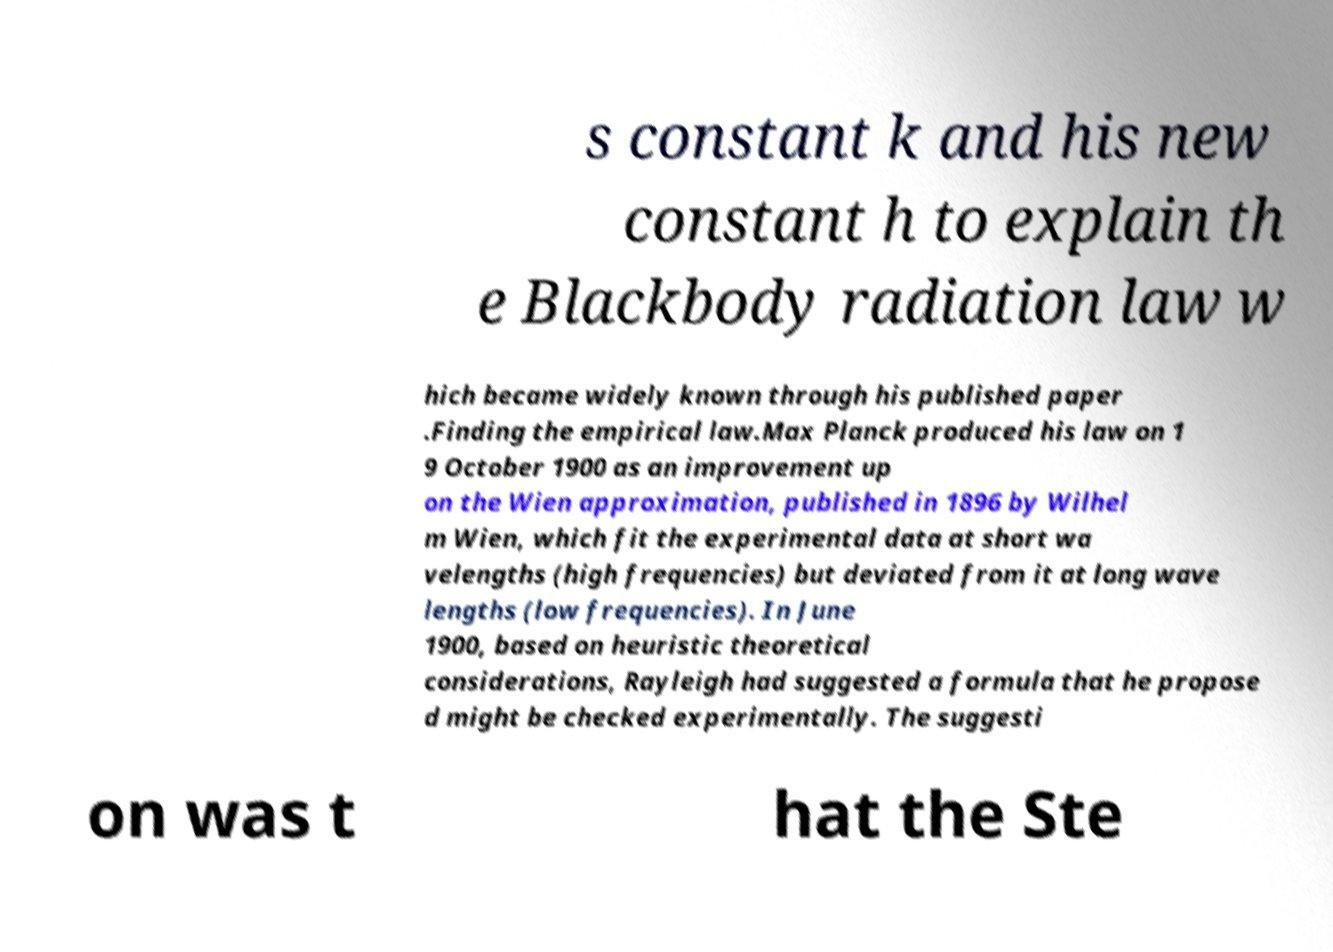I need the written content from this picture converted into text. Can you do that? s constant k and his new constant h to explain th e Blackbody radiation law w hich became widely known through his published paper .Finding the empirical law.Max Planck produced his law on 1 9 October 1900 as an improvement up on the Wien approximation, published in 1896 by Wilhel m Wien, which fit the experimental data at short wa velengths (high frequencies) but deviated from it at long wave lengths (low frequencies). In June 1900, based on heuristic theoretical considerations, Rayleigh had suggested a formula that he propose d might be checked experimentally. The suggesti on was t hat the Ste 